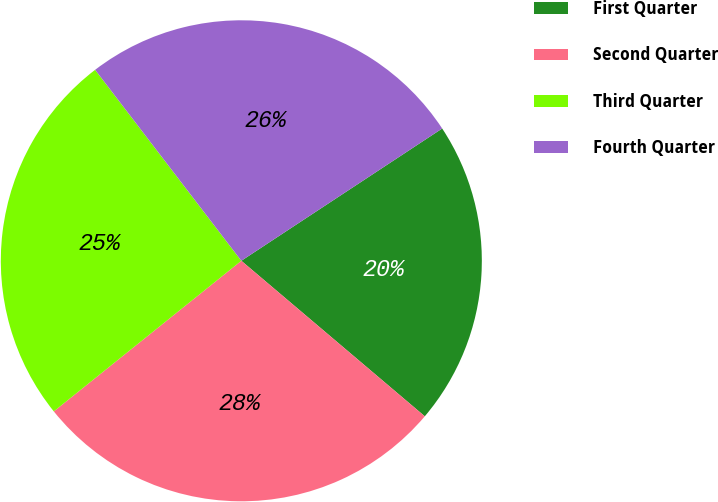Convert chart to OTSL. <chart><loc_0><loc_0><loc_500><loc_500><pie_chart><fcel>First Quarter<fcel>Second Quarter<fcel>Third Quarter<fcel>Fourth Quarter<nl><fcel>20.46%<fcel>28.04%<fcel>25.37%<fcel>26.13%<nl></chart> 